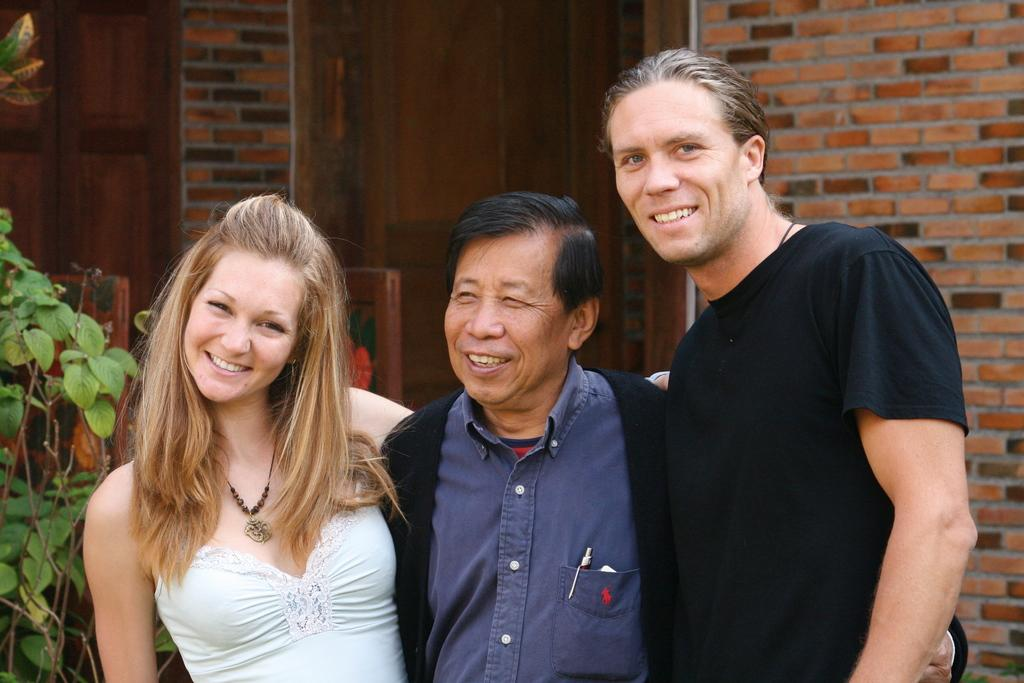How many people are in the image? There are two men and a woman in the image, making a total of three people. What is the facial expression of the people in the image? The people in the image are smiling. What are the people in the image doing? The people are posing for the picture. What can be seen on the left side of the image? There is a plant on the left side of the image. What is visible in the background of the image? There is a wall and doors in the background of the image. What type of transport is the writer using in the image? There is no writer or transport present in the image. What day of the week is it in the image? The day of the week cannot be determined from the image. 